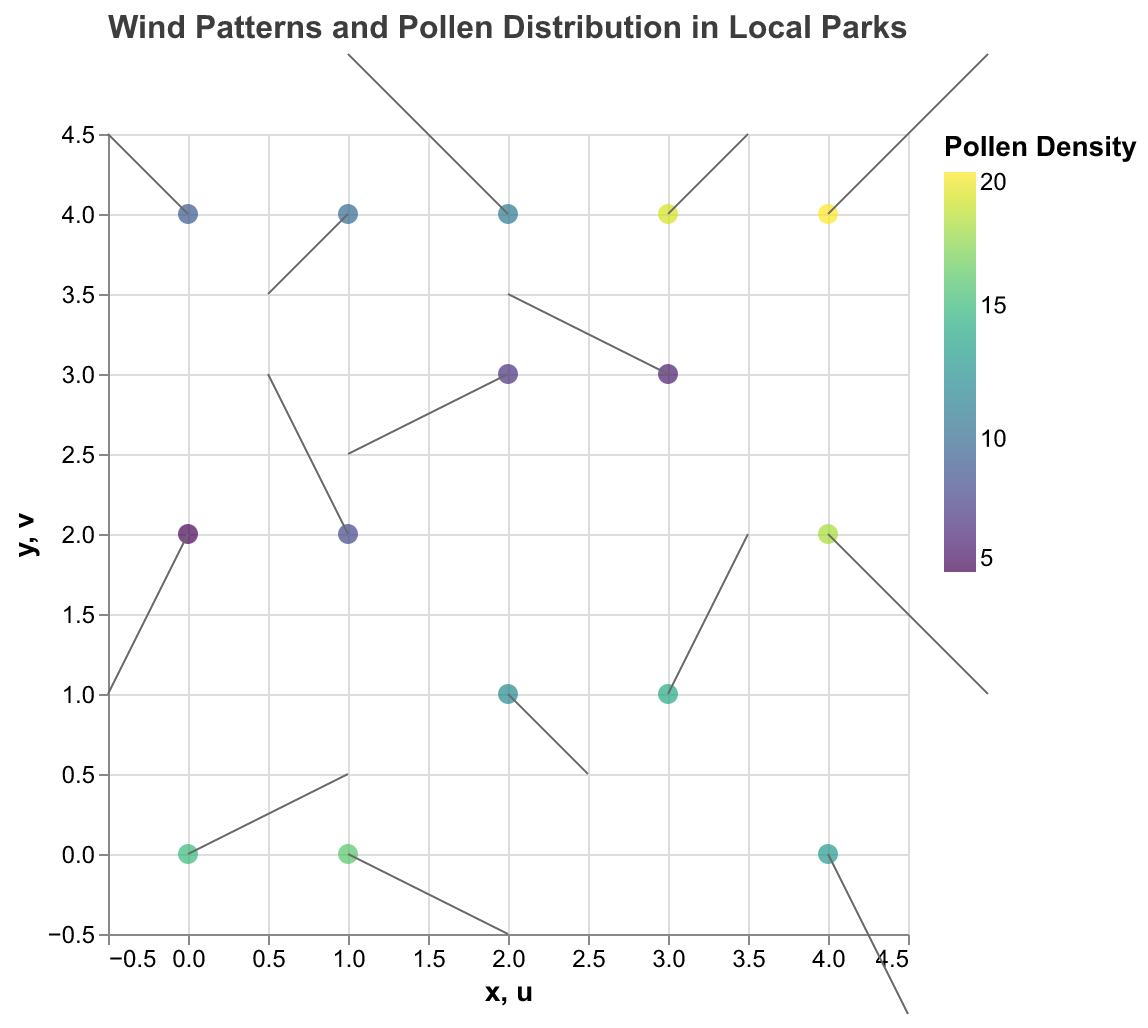What is the title of the figure? The title is found at the top of the figure, and it reads "Wind Patterns and Pollen Distribution in Local Parks"
Answer: Wind Patterns and Pollen Distribution in Local Parks Which axis represents the horizontal position? The horizontal axis is the 'x' axis, which is labeled as seen in the figure
Answer: x-axis What is the color of the data points indicating pollen density at each location? The data points are colored using a viridis color scale to represent different pollen densities
Answer: Viridis color scale How many data points have a pollen density greater than 15? The data points with pollen densities greater than 15 can be identified by looking at the color scale and selecting the corresponding colored points
Answer: 5 Which point has the highest pollen density and what is its value? The highest pollen density can be found by looking at the point with the color corresponding to the maximum value on the color scale. The precise value can be found in the tooltip by hovering over the point
Answer: The point at (4, 4) with a pollen density of 20 Which direction is the wind blowing at the point (1, 0)? The wind direction at this point can be determined by the direction of the arrow originating from (1, 0). The arrow points to the right and slightly downward
Answer: Right and slightly downward Calculate the average pollen density of all points. To find the average pollen density, sum all the pollen densities and divide by the number of data points. The total density is 193 (15+8+12+6+18+10+14+7+20+9+13+11+16+19+5), and there are 15 data points: 193/15
Answer: 12.87 Which point has a wind vector pointing directly upward? A wind vector pointing directly upward has a vertical offset (v) greater than zero and a horizontal offset (u) of 0. Looking at all data points that meet this criteria, none fits directly
Answer: None Determine the sum of pollen densities at all points where the wind vector lies purely in the negative y-direction. Points with purely negative y-direction wind vectors have v less than zero and u equal to zero. However, none of the points satisfy this condition; the points have varied u and v directions
Answer: 0 Compare the wind strength between points (4,2) and (0,2). Which has the stronger wind and what are their strengths? Wind strength can be calculated as the vector magnitude = √(u² + v²). For (4,2), the strength is √(2² + (-2)²) = √8; for (0,2), it's √((-1)² + (-2)²) = √5. Therefore, (4,2) has a stronger wind
Answer: (4, 2) with strength √8 